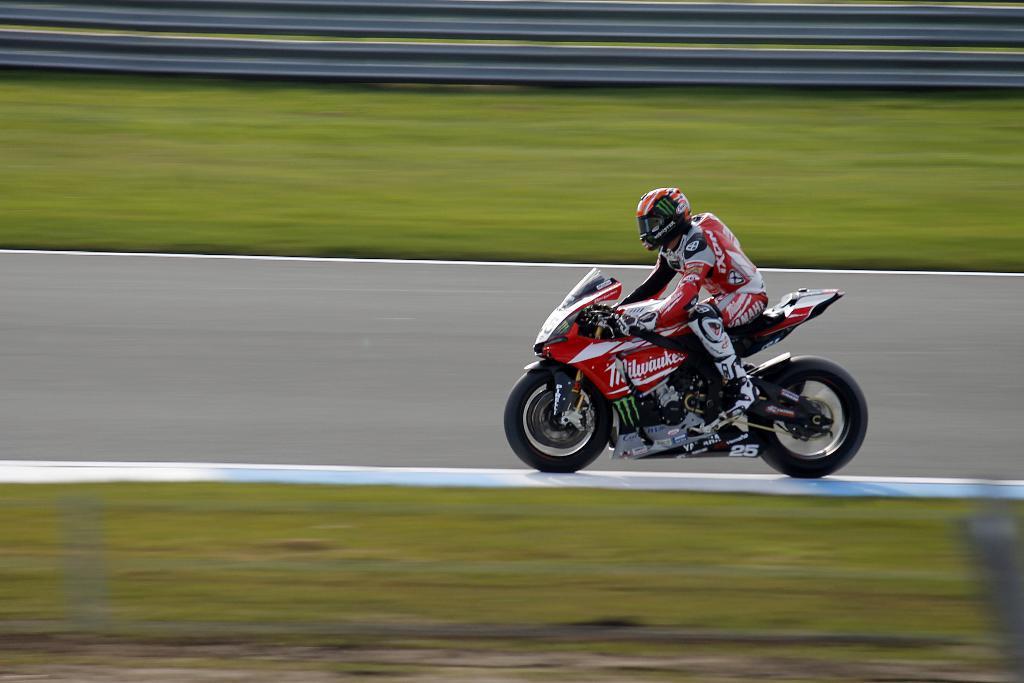Please provide a concise description of this image. This picture is clicked outside. On the right we can see a person wearing helmet and riding a red color bike and we can see the green grass and some other objects. 